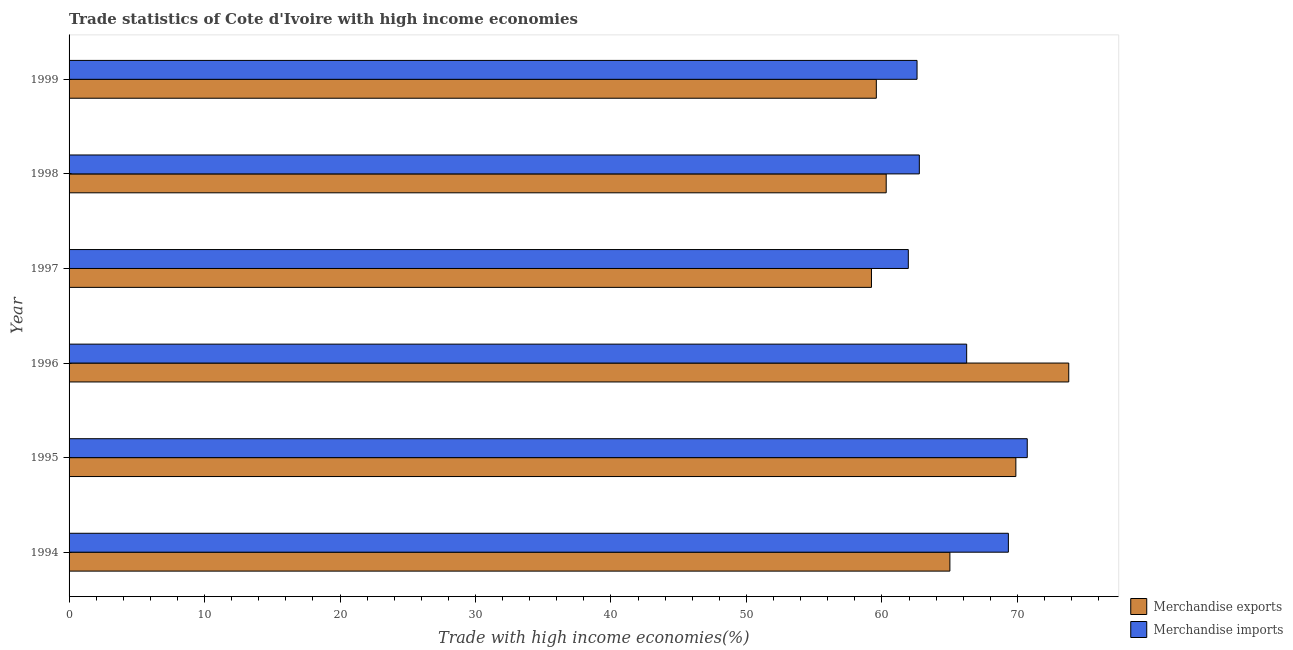Are the number of bars on each tick of the Y-axis equal?
Keep it short and to the point. Yes. How many bars are there on the 4th tick from the top?
Your answer should be very brief. 2. How many bars are there on the 2nd tick from the bottom?
Your answer should be very brief. 2. In how many cases, is the number of bars for a given year not equal to the number of legend labels?
Offer a terse response. 0. What is the merchandise imports in 1999?
Make the answer very short. 62.59. Across all years, what is the maximum merchandise imports?
Provide a short and direct response. 70.73. Across all years, what is the minimum merchandise imports?
Offer a very short reply. 61.95. In which year was the merchandise exports maximum?
Make the answer very short. 1996. What is the total merchandise imports in the graph?
Offer a very short reply. 393.61. What is the difference between the merchandise exports in 1996 and that in 1998?
Keep it short and to the point. 13.47. What is the difference between the merchandise exports in 1999 and the merchandise imports in 1996?
Provide a succinct answer. -6.67. What is the average merchandise imports per year?
Make the answer very short. 65.6. In the year 1995, what is the difference between the merchandise exports and merchandise imports?
Make the answer very short. -0.84. Is the merchandise exports in 1995 less than that in 1998?
Ensure brevity in your answer.  No. Is the difference between the merchandise exports in 1995 and 1996 greater than the difference between the merchandise imports in 1995 and 1996?
Offer a very short reply. No. What is the difference between the highest and the second highest merchandise imports?
Provide a short and direct response. 1.39. What is the difference between the highest and the lowest merchandise imports?
Provide a short and direct response. 8.78. In how many years, is the merchandise exports greater than the average merchandise exports taken over all years?
Give a very brief answer. 3. What does the 1st bar from the top in 1998 represents?
Keep it short and to the point. Merchandise imports. How many bars are there?
Your response must be concise. 12. How many years are there in the graph?
Offer a very short reply. 6. Does the graph contain any zero values?
Offer a very short reply. No. Does the graph contain grids?
Give a very brief answer. No. How many legend labels are there?
Make the answer very short. 2. How are the legend labels stacked?
Make the answer very short. Vertical. What is the title of the graph?
Offer a terse response. Trade statistics of Cote d'Ivoire with high income economies. Does "Diarrhea" appear as one of the legend labels in the graph?
Your answer should be compact. No. What is the label or title of the X-axis?
Your answer should be very brief. Trade with high income economies(%). What is the label or title of the Y-axis?
Give a very brief answer. Year. What is the Trade with high income economies(%) of Merchandise exports in 1994?
Give a very brief answer. 65.02. What is the Trade with high income economies(%) of Merchandise imports in 1994?
Make the answer very short. 69.33. What is the Trade with high income economies(%) of Merchandise exports in 1995?
Give a very brief answer. 69.88. What is the Trade with high income economies(%) of Merchandise imports in 1995?
Ensure brevity in your answer.  70.73. What is the Trade with high income economies(%) in Merchandise exports in 1996?
Ensure brevity in your answer.  73.79. What is the Trade with high income economies(%) of Merchandise imports in 1996?
Your response must be concise. 66.25. What is the Trade with high income economies(%) of Merchandise exports in 1997?
Provide a succinct answer. 59.23. What is the Trade with high income economies(%) of Merchandise imports in 1997?
Offer a terse response. 61.95. What is the Trade with high income economies(%) in Merchandise exports in 1998?
Offer a very short reply. 60.32. What is the Trade with high income economies(%) in Merchandise imports in 1998?
Give a very brief answer. 62.76. What is the Trade with high income economies(%) in Merchandise exports in 1999?
Your response must be concise. 59.59. What is the Trade with high income economies(%) of Merchandise imports in 1999?
Your answer should be very brief. 62.59. Across all years, what is the maximum Trade with high income economies(%) in Merchandise exports?
Ensure brevity in your answer.  73.79. Across all years, what is the maximum Trade with high income economies(%) of Merchandise imports?
Provide a short and direct response. 70.73. Across all years, what is the minimum Trade with high income economies(%) in Merchandise exports?
Give a very brief answer. 59.23. Across all years, what is the minimum Trade with high income economies(%) of Merchandise imports?
Offer a terse response. 61.95. What is the total Trade with high income economies(%) in Merchandise exports in the graph?
Your answer should be compact. 387.82. What is the total Trade with high income economies(%) of Merchandise imports in the graph?
Keep it short and to the point. 393.61. What is the difference between the Trade with high income economies(%) in Merchandise exports in 1994 and that in 1995?
Your response must be concise. -4.87. What is the difference between the Trade with high income economies(%) of Merchandise imports in 1994 and that in 1995?
Make the answer very short. -1.39. What is the difference between the Trade with high income economies(%) in Merchandise exports in 1994 and that in 1996?
Offer a terse response. -8.77. What is the difference between the Trade with high income economies(%) in Merchandise imports in 1994 and that in 1996?
Offer a terse response. 3.08. What is the difference between the Trade with high income economies(%) of Merchandise exports in 1994 and that in 1997?
Your answer should be compact. 5.79. What is the difference between the Trade with high income economies(%) in Merchandise imports in 1994 and that in 1997?
Your answer should be very brief. 7.39. What is the difference between the Trade with high income economies(%) in Merchandise exports in 1994 and that in 1998?
Provide a succinct answer. 4.7. What is the difference between the Trade with high income economies(%) in Merchandise imports in 1994 and that in 1998?
Make the answer very short. 6.57. What is the difference between the Trade with high income economies(%) in Merchandise exports in 1994 and that in 1999?
Give a very brief answer. 5.43. What is the difference between the Trade with high income economies(%) in Merchandise imports in 1994 and that in 1999?
Offer a very short reply. 6.74. What is the difference between the Trade with high income economies(%) in Merchandise exports in 1995 and that in 1996?
Your response must be concise. -3.9. What is the difference between the Trade with high income economies(%) in Merchandise imports in 1995 and that in 1996?
Provide a short and direct response. 4.47. What is the difference between the Trade with high income economies(%) in Merchandise exports in 1995 and that in 1997?
Offer a very short reply. 10.66. What is the difference between the Trade with high income economies(%) of Merchandise imports in 1995 and that in 1997?
Your response must be concise. 8.78. What is the difference between the Trade with high income economies(%) of Merchandise exports in 1995 and that in 1998?
Offer a terse response. 9.57. What is the difference between the Trade with high income economies(%) in Merchandise imports in 1995 and that in 1998?
Make the answer very short. 7.97. What is the difference between the Trade with high income economies(%) of Merchandise exports in 1995 and that in 1999?
Give a very brief answer. 10.3. What is the difference between the Trade with high income economies(%) in Merchandise imports in 1995 and that in 1999?
Give a very brief answer. 8.14. What is the difference between the Trade with high income economies(%) of Merchandise exports in 1996 and that in 1997?
Provide a short and direct response. 14.56. What is the difference between the Trade with high income economies(%) of Merchandise imports in 1996 and that in 1997?
Provide a succinct answer. 4.31. What is the difference between the Trade with high income economies(%) in Merchandise exports in 1996 and that in 1998?
Provide a short and direct response. 13.47. What is the difference between the Trade with high income economies(%) in Merchandise imports in 1996 and that in 1998?
Offer a very short reply. 3.49. What is the difference between the Trade with high income economies(%) of Merchandise exports in 1996 and that in 1999?
Ensure brevity in your answer.  14.2. What is the difference between the Trade with high income economies(%) in Merchandise imports in 1996 and that in 1999?
Offer a terse response. 3.66. What is the difference between the Trade with high income economies(%) of Merchandise exports in 1997 and that in 1998?
Your response must be concise. -1.09. What is the difference between the Trade with high income economies(%) of Merchandise imports in 1997 and that in 1998?
Ensure brevity in your answer.  -0.81. What is the difference between the Trade with high income economies(%) in Merchandise exports in 1997 and that in 1999?
Your answer should be compact. -0.36. What is the difference between the Trade with high income economies(%) of Merchandise imports in 1997 and that in 1999?
Your answer should be very brief. -0.64. What is the difference between the Trade with high income economies(%) in Merchandise exports in 1998 and that in 1999?
Provide a short and direct response. 0.73. What is the difference between the Trade with high income economies(%) in Merchandise imports in 1998 and that in 1999?
Ensure brevity in your answer.  0.17. What is the difference between the Trade with high income economies(%) in Merchandise exports in 1994 and the Trade with high income economies(%) in Merchandise imports in 1995?
Your answer should be compact. -5.71. What is the difference between the Trade with high income economies(%) of Merchandise exports in 1994 and the Trade with high income economies(%) of Merchandise imports in 1996?
Offer a terse response. -1.24. What is the difference between the Trade with high income economies(%) in Merchandise exports in 1994 and the Trade with high income economies(%) in Merchandise imports in 1997?
Keep it short and to the point. 3.07. What is the difference between the Trade with high income economies(%) of Merchandise exports in 1994 and the Trade with high income economies(%) of Merchandise imports in 1998?
Provide a succinct answer. 2.26. What is the difference between the Trade with high income economies(%) of Merchandise exports in 1994 and the Trade with high income economies(%) of Merchandise imports in 1999?
Provide a succinct answer. 2.43. What is the difference between the Trade with high income economies(%) in Merchandise exports in 1995 and the Trade with high income economies(%) in Merchandise imports in 1996?
Offer a terse response. 3.63. What is the difference between the Trade with high income economies(%) of Merchandise exports in 1995 and the Trade with high income economies(%) of Merchandise imports in 1997?
Ensure brevity in your answer.  7.94. What is the difference between the Trade with high income economies(%) of Merchandise exports in 1995 and the Trade with high income economies(%) of Merchandise imports in 1998?
Make the answer very short. 7.12. What is the difference between the Trade with high income economies(%) in Merchandise exports in 1995 and the Trade with high income economies(%) in Merchandise imports in 1999?
Your answer should be very brief. 7.29. What is the difference between the Trade with high income economies(%) in Merchandise exports in 1996 and the Trade with high income economies(%) in Merchandise imports in 1997?
Keep it short and to the point. 11.84. What is the difference between the Trade with high income economies(%) of Merchandise exports in 1996 and the Trade with high income economies(%) of Merchandise imports in 1998?
Keep it short and to the point. 11.03. What is the difference between the Trade with high income economies(%) in Merchandise exports in 1996 and the Trade with high income economies(%) in Merchandise imports in 1999?
Your response must be concise. 11.2. What is the difference between the Trade with high income economies(%) of Merchandise exports in 1997 and the Trade with high income economies(%) of Merchandise imports in 1998?
Keep it short and to the point. -3.53. What is the difference between the Trade with high income economies(%) of Merchandise exports in 1997 and the Trade with high income economies(%) of Merchandise imports in 1999?
Offer a terse response. -3.36. What is the difference between the Trade with high income economies(%) in Merchandise exports in 1998 and the Trade with high income economies(%) in Merchandise imports in 1999?
Ensure brevity in your answer.  -2.28. What is the average Trade with high income economies(%) of Merchandise exports per year?
Provide a succinct answer. 64.64. What is the average Trade with high income economies(%) in Merchandise imports per year?
Your response must be concise. 65.6. In the year 1994, what is the difference between the Trade with high income economies(%) in Merchandise exports and Trade with high income economies(%) in Merchandise imports?
Offer a terse response. -4.32. In the year 1995, what is the difference between the Trade with high income economies(%) in Merchandise exports and Trade with high income economies(%) in Merchandise imports?
Ensure brevity in your answer.  -0.84. In the year 1996, what is the difference between the Trade with high income economies(%) in Merchandise exports and Trade with high income economies(%) in Merchandise imports?
Your answer should be very brief. 7.53. In the year 1997, what is the difference between the Trade with high income economies(%) of Merchandise exports and Trade with high income economies(%) of Merchandise imports?
Offer a very short reply. -2.72. In the year 1998, what is the difference between the Trade with high income economies(%) of Merchandise exports and Trade with high income economies(%) of Merchandise imports?
Offer a terse response. -2.44. In the year 1999, what is the difference between the Trade with high income economies(%) of Merchandise exports and Trade with high income economies(%) of Merchandise imports?
Give a very brief answer. -3.01. What is the ratio of the Trade with high income economies(%) in Merchandise exports in 1994 to that in 1995?
Provide a succinct answer. 0.93. What is the ratio of the Trade with high income economies(%) of Merchandise imports in 1994 to that in 1995?
Your response must be concise. 0.98. What is the ratio of the Trade with high income economies(%) of Merchandise exports in 1994 to that in 1996?
Give a very brief answer. 0.88. What is the ratio of the Trade with high income economies(%) in Merchandise imports in 1994 to that in 1996?
Your response must be concise. 1.05. What is the ratio of the Trade with high income economies(%) of Merchandise exports in 1994 to that in 1997?
Your answer should be very brief. 1.1. What is the ratio of the Trade with high income economies(%) of Merchandise imports in 1994 to that in 1997?
Offer a very short reply. 1.12. What is the ratio of the Trade with high income economies(%) of Merchandise exports in 1994 to that in 1998?
Offer a very short reply. 1.08. What is the ratio of the Trade with high income economies(%) of Merchandise imports in 1994 to that in 1998?
Give a very brief answer. 1.1. What is the ratio of the Trade with high income economies(%) of Merchandise exports in 1994 to that in 1999?
Offer a terse response. 1.09. What is the ratio of the Trade with high income economies(%) of Merchandise imports in 1994 to that in 1999?
Your answer should be compact. 1.11. What is the ratio of the Trade with high income economies(%) of Merchandise exports in 1995 to that in 1996?
Provide a succinct answer. 0.95. What is the ratio of the Trade with high income economies(%) of Merchandise imports in 1995 to that in 1996?
Provide a succinct answer. 1.07. What is the ratio of the Trade with high income economies(%) in Merchandise exports in 1995 to that in 1997?
Make the answer very short. 1.18. What is the ratio of the Trade with high income economies(%) of Merchandise imports in 1995 to that in 1997?
Keep it short and to the point. 1.14. What is the ratio of the Trade with high income economies(%) of Merchandise exports in 1995 to that in 1998?
Your answer should be very brief. 1.16. What is the ratio of the Trade with high income economies(%) in Merchandise imports in 1995 to that in 1998?
Provide a short and direct response. 1.13. What is the ratio of the Trade with high income economies(%) of Merchandise exports in 1995 to that in 1999?
Your answer should be very brief. 1.17. What is the ratio of the Trade with high income economies(%) of Merchandise imports in 1995 to that in 1999?
Give a very brief answer. 1.13. What is the ratio of the Trade with high income economies(%) in Merchandise exports in 1996 to that in 1997?
Keep it short and to the point. 1.25. What is the ratio of the Trade with high income economies(%) in Merchandise imports in 1996 to that in 1997?
Provide a short and direct response. 1.07. What is the ratio of the Trade with high income economies(%) of Merchandise exports in 1996 to that in 1998?
Provide a succinct answer. 1.22. What is the ratio of the Trade with high income economies(%) of Merchandise imports in 1996 to that in 1998?
Make the answer very short. 1.06. What is the ratio of the Trade with high income economies(%) in Merchandise exports in 1996 to that in 1999?
Make the answer very short. 1.24. What is the ratio of the Trade with high income economies(%) of Merchandise imports in 1996 to that in 1999?
Offer a very short reply. 1.06. What is the ratio of the Trade with high income economies(%) in Merchandise imports in 1997 to that in 1998?
Your answer should be very brief. 0.99. What is the ratio of the Trade with high income economies(%) of Merchandise exports in 1998 to that in 1999?
Your answer should be compact. 1.01. What is the difference between the highest and the second highest Trade with high income economies(%) in Merchandise exports?
Your answer should be very brief. 3.9. What is the difference between the highest and the second highest Trade with high income economies(%) of Merchandise imports?
Offer a terse response. 1.39. What is the difference between the highest and the lowest Trade with high income economies(%) in Merchandise exports?
Keep it short and to the point. 14.56. What is the difference between the highest and the lowest Trade with high income economies(%) in Merchandise imports?
Offer a very short reply. 8.78. 